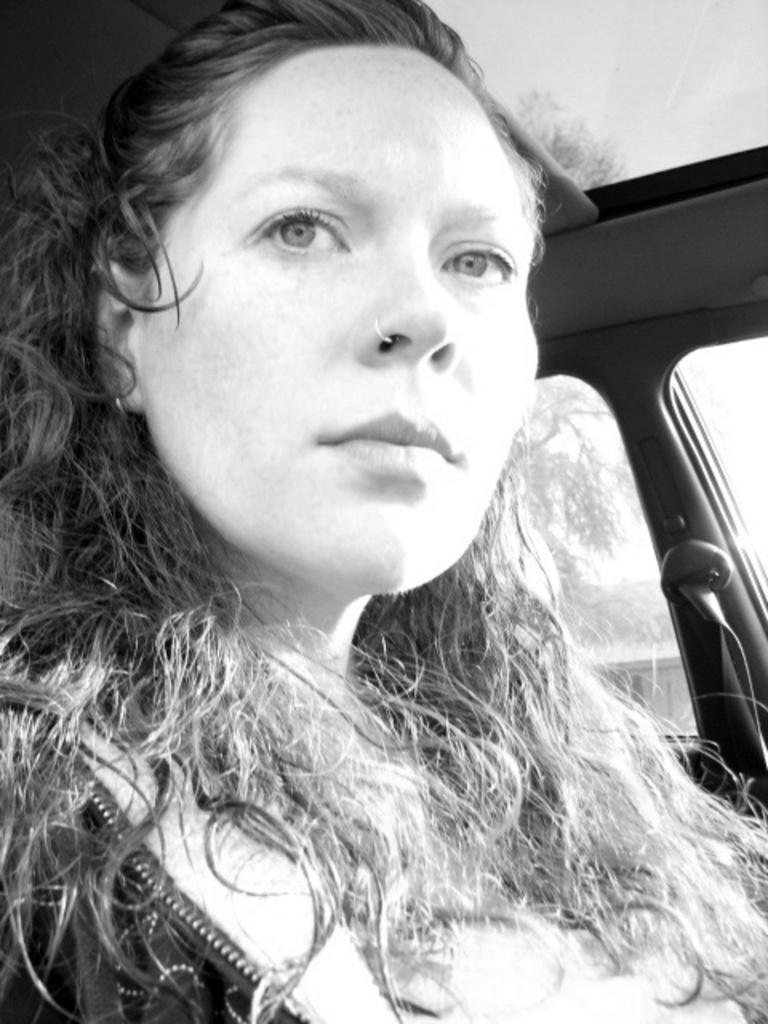Please provide a concise description of this image. This is a black and white image. I can see a woman sitting. I think this picture was taken inside the vehicle. 